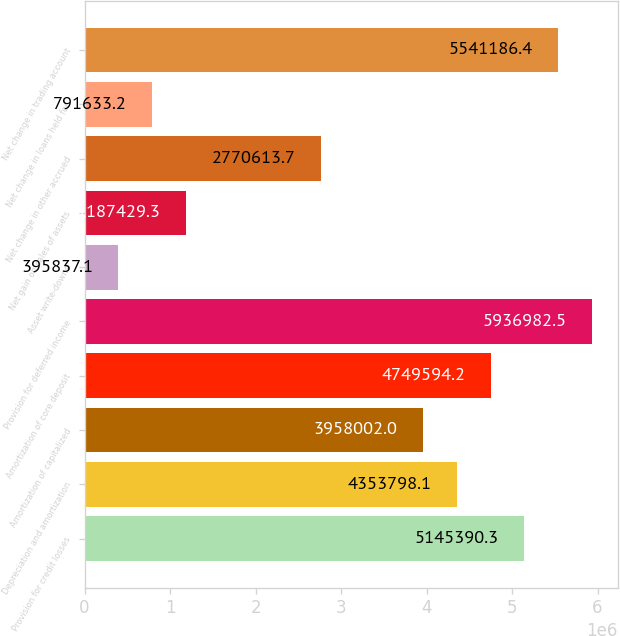<chart> <loc_0><loc_0><loc_500><loc_500><bar_chart><fcel>Provision for credit losses<fcel>Depreciation and amortization<fcel>Amortization of capitalized<fcel>Amortization of core deposit<fcel>Provision for deferred income<fcel>Asset write-downs<fcel>Net gain on sales of assets<fcel>Net change in other accrued<fcel>Net change in loans held for<fcel>Net change in trading account<nl><fcel>5.14539e+06<fcel>4.3538e+06<fcel>3.958e+06<fcel>4.74959e+06<fcel>5.93698e+06<fcel>395837<fcel>1.18743e+06<fcel>2.77061e+06<fcel>791633<fcel>5.54119e+06<nl></chart> 